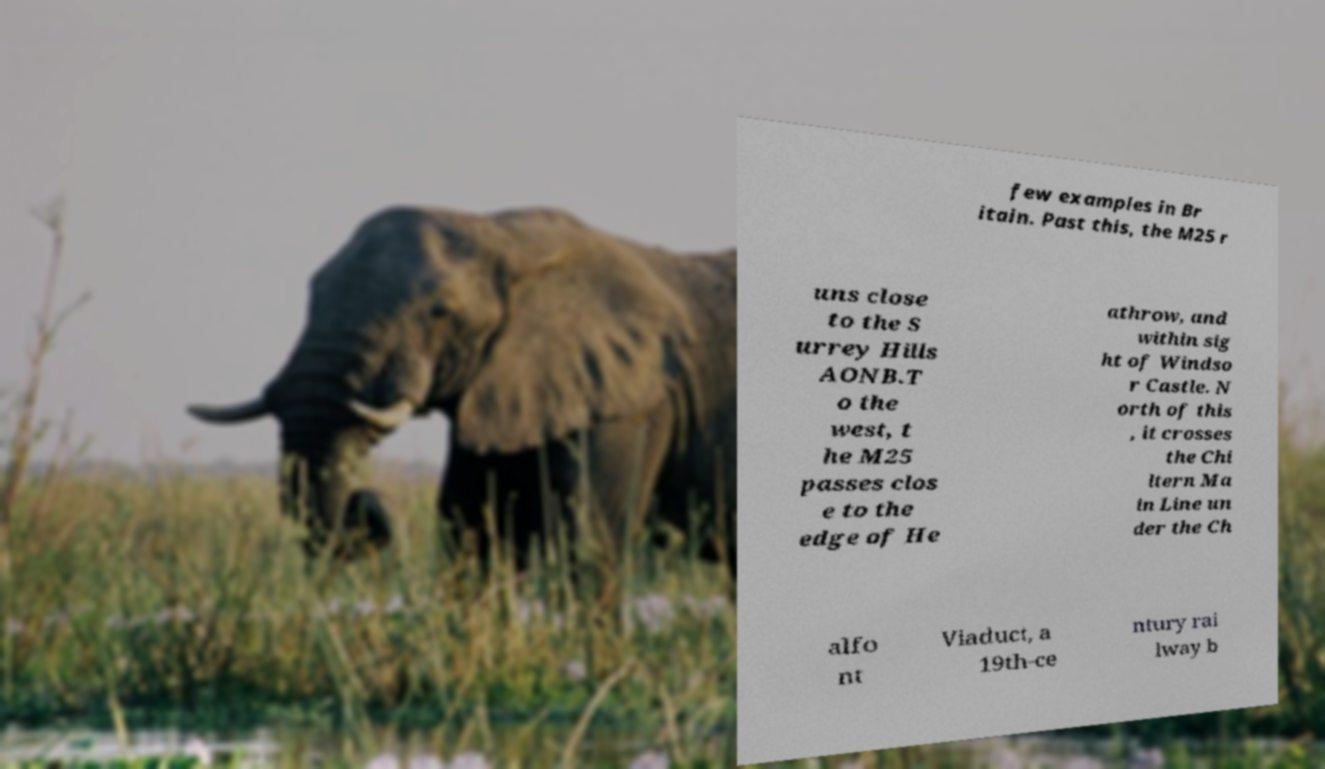Please read and relay the text visible in this image. What does it say? few examples in Br itain. Past this, the M25 r uns close to the S urrey Hills AONB.T o the west, t he M25 passes clos e to the edge of He athrow, and within sig ht of Windso r Castle. N orth of this , it crosses the Chi ltern Ma in Line un der the Ch alfo nt Viaduct, a 19th-ce ntury rai lway b 